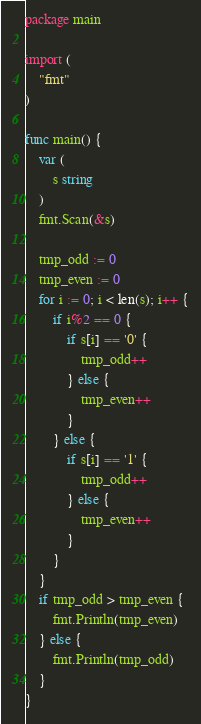<code> <loc_0><loc_0><loc_500><loc_500><_Go_>package main

import (
	"fmt"
)

func main() {
	var (
		s string
	)
	fmt.Scan(&s)

	tmp_odd := 0
	tmp_even := 0
	for i := 0; i < len(s); i++ {
		if i%2 == 0 {
			if s[i] == '0' {
				tmp_odd++
			} else {
				tmp_even++
			}
		} else {
			if s[i] == '1' {
				tmp_odd++
			} else {
				tmp_even++
			}
		}
	}
	if tmp_odd > tmp_even {
		fmt.Println(tmp_even)
	} else {
		fmt.Println(tmp_odd)
	}
}
</code> 